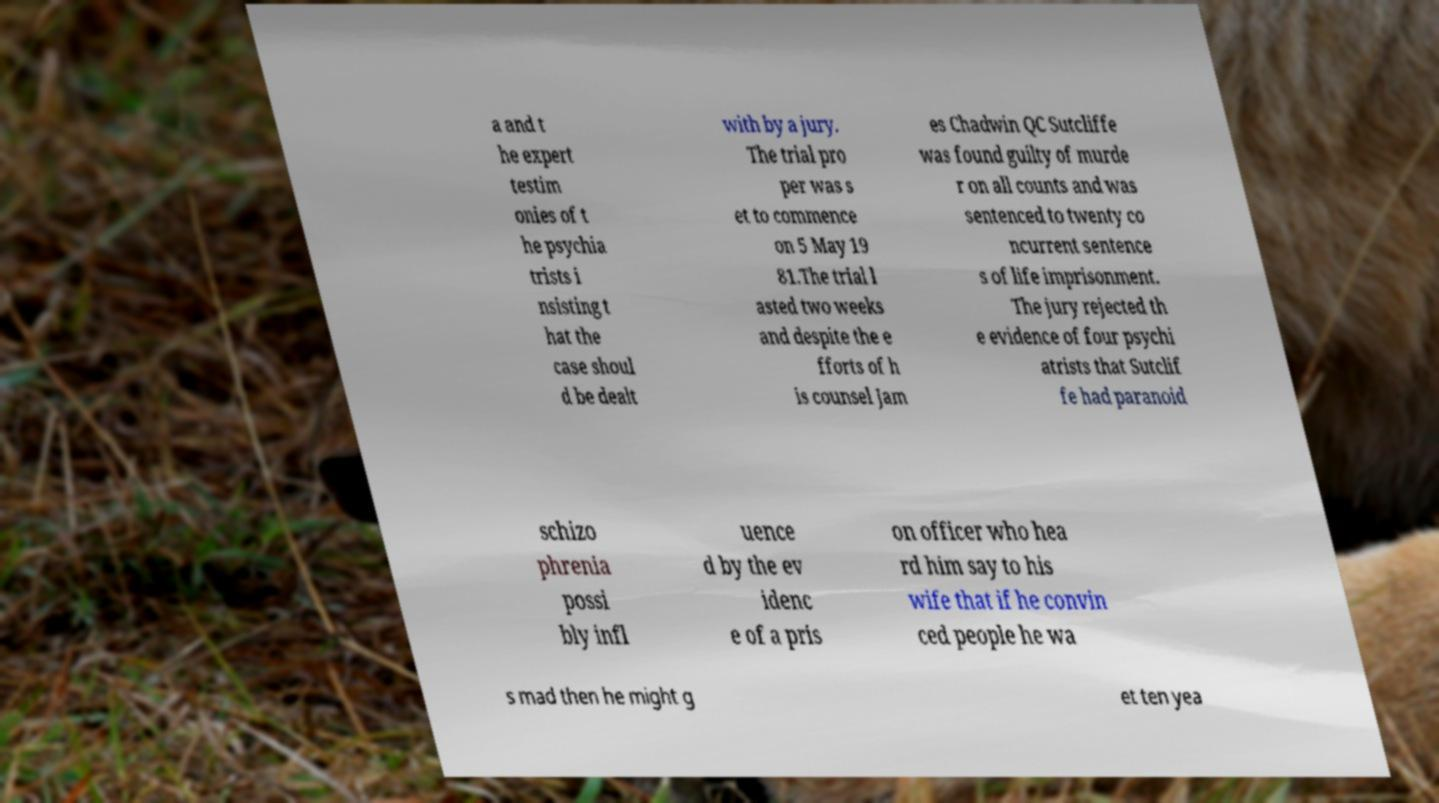For documentation purposes, I need the text within this image transcribed. Could you provide that? a and t he expert testim onies of t he psychia trists i nsisting t hat the case shoul d be dealt with by a jury. The trial pro per was s et to commence on 5 May 19 81.The trial l asted two weeks and despite the e fforts of h is counsel Jam es Chadwin QC Sutcliffe was found guilty of murde r on all counts and was sentenced to twenty co ncurrent sentence s of life imprisonment. The jury rejected th e evidence of four psychi atrists that Sutclif fe had paranoid schizo phrenia possi bly infl uence d by the ev idenc e of a pris on officer who hea rd him say to his wife that if he convin ced people he wa s mad then he might g et ten yea 